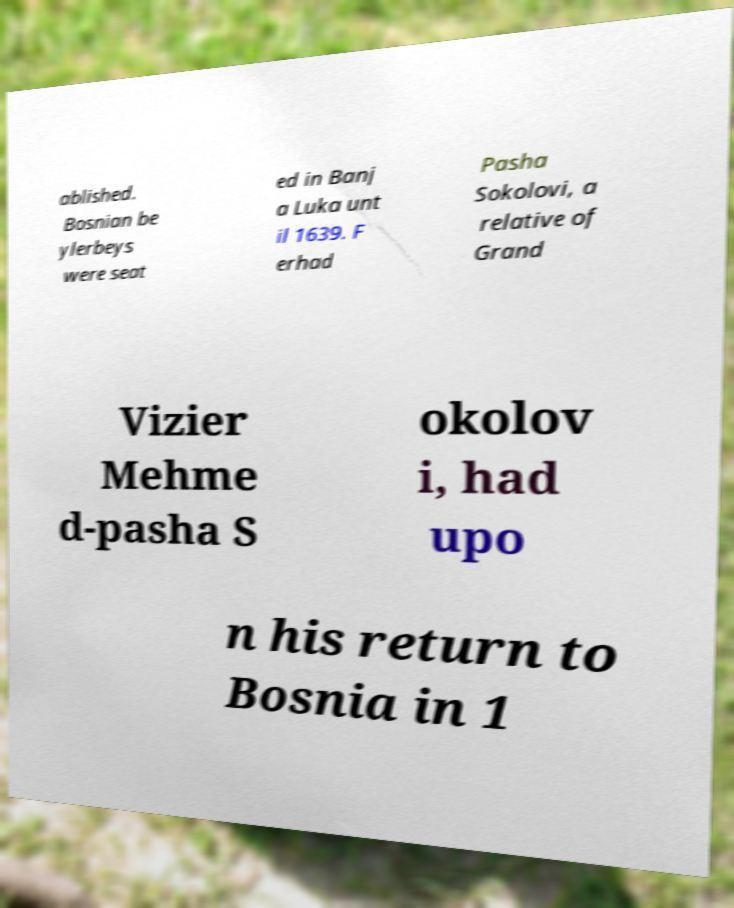What messages or text are displayed in this image? I need them in a readable, typed format. ablished. Bosnian be ylerbeys were seat ed in Banj a Luka unt il 1639. F erhad Pasha Sokolovi, a relative of Grand Vizier Mehme d-pasha S okolov i, had upo n his return to Bosnia in 1 